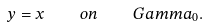<formula> <loc_0><loc_0><loc_500><loc_500>y = x \quad o n \quad G a m m a _ { 0 } .</formula> 